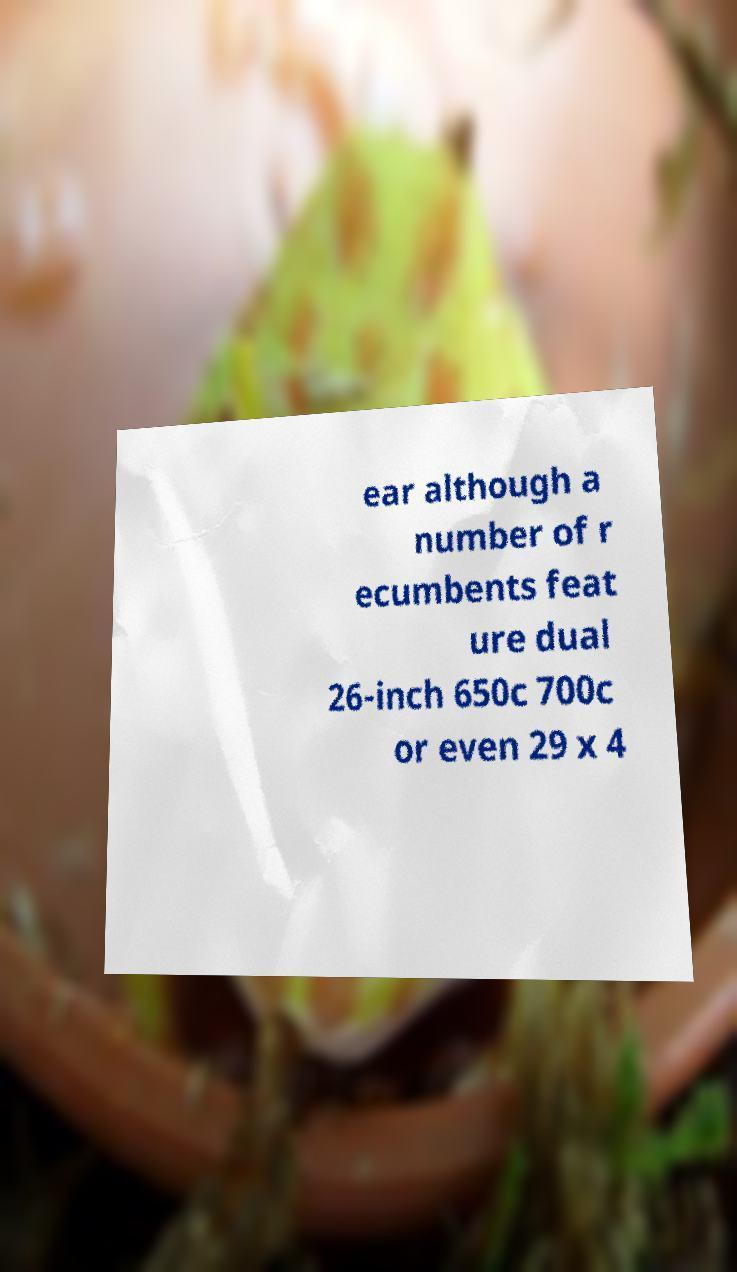Could you assist in decoding the text presented in this image and type it out clearly? ear although a number of r ecumbents feat ure dual 26-inch 650c 700c or even 29 x 4 